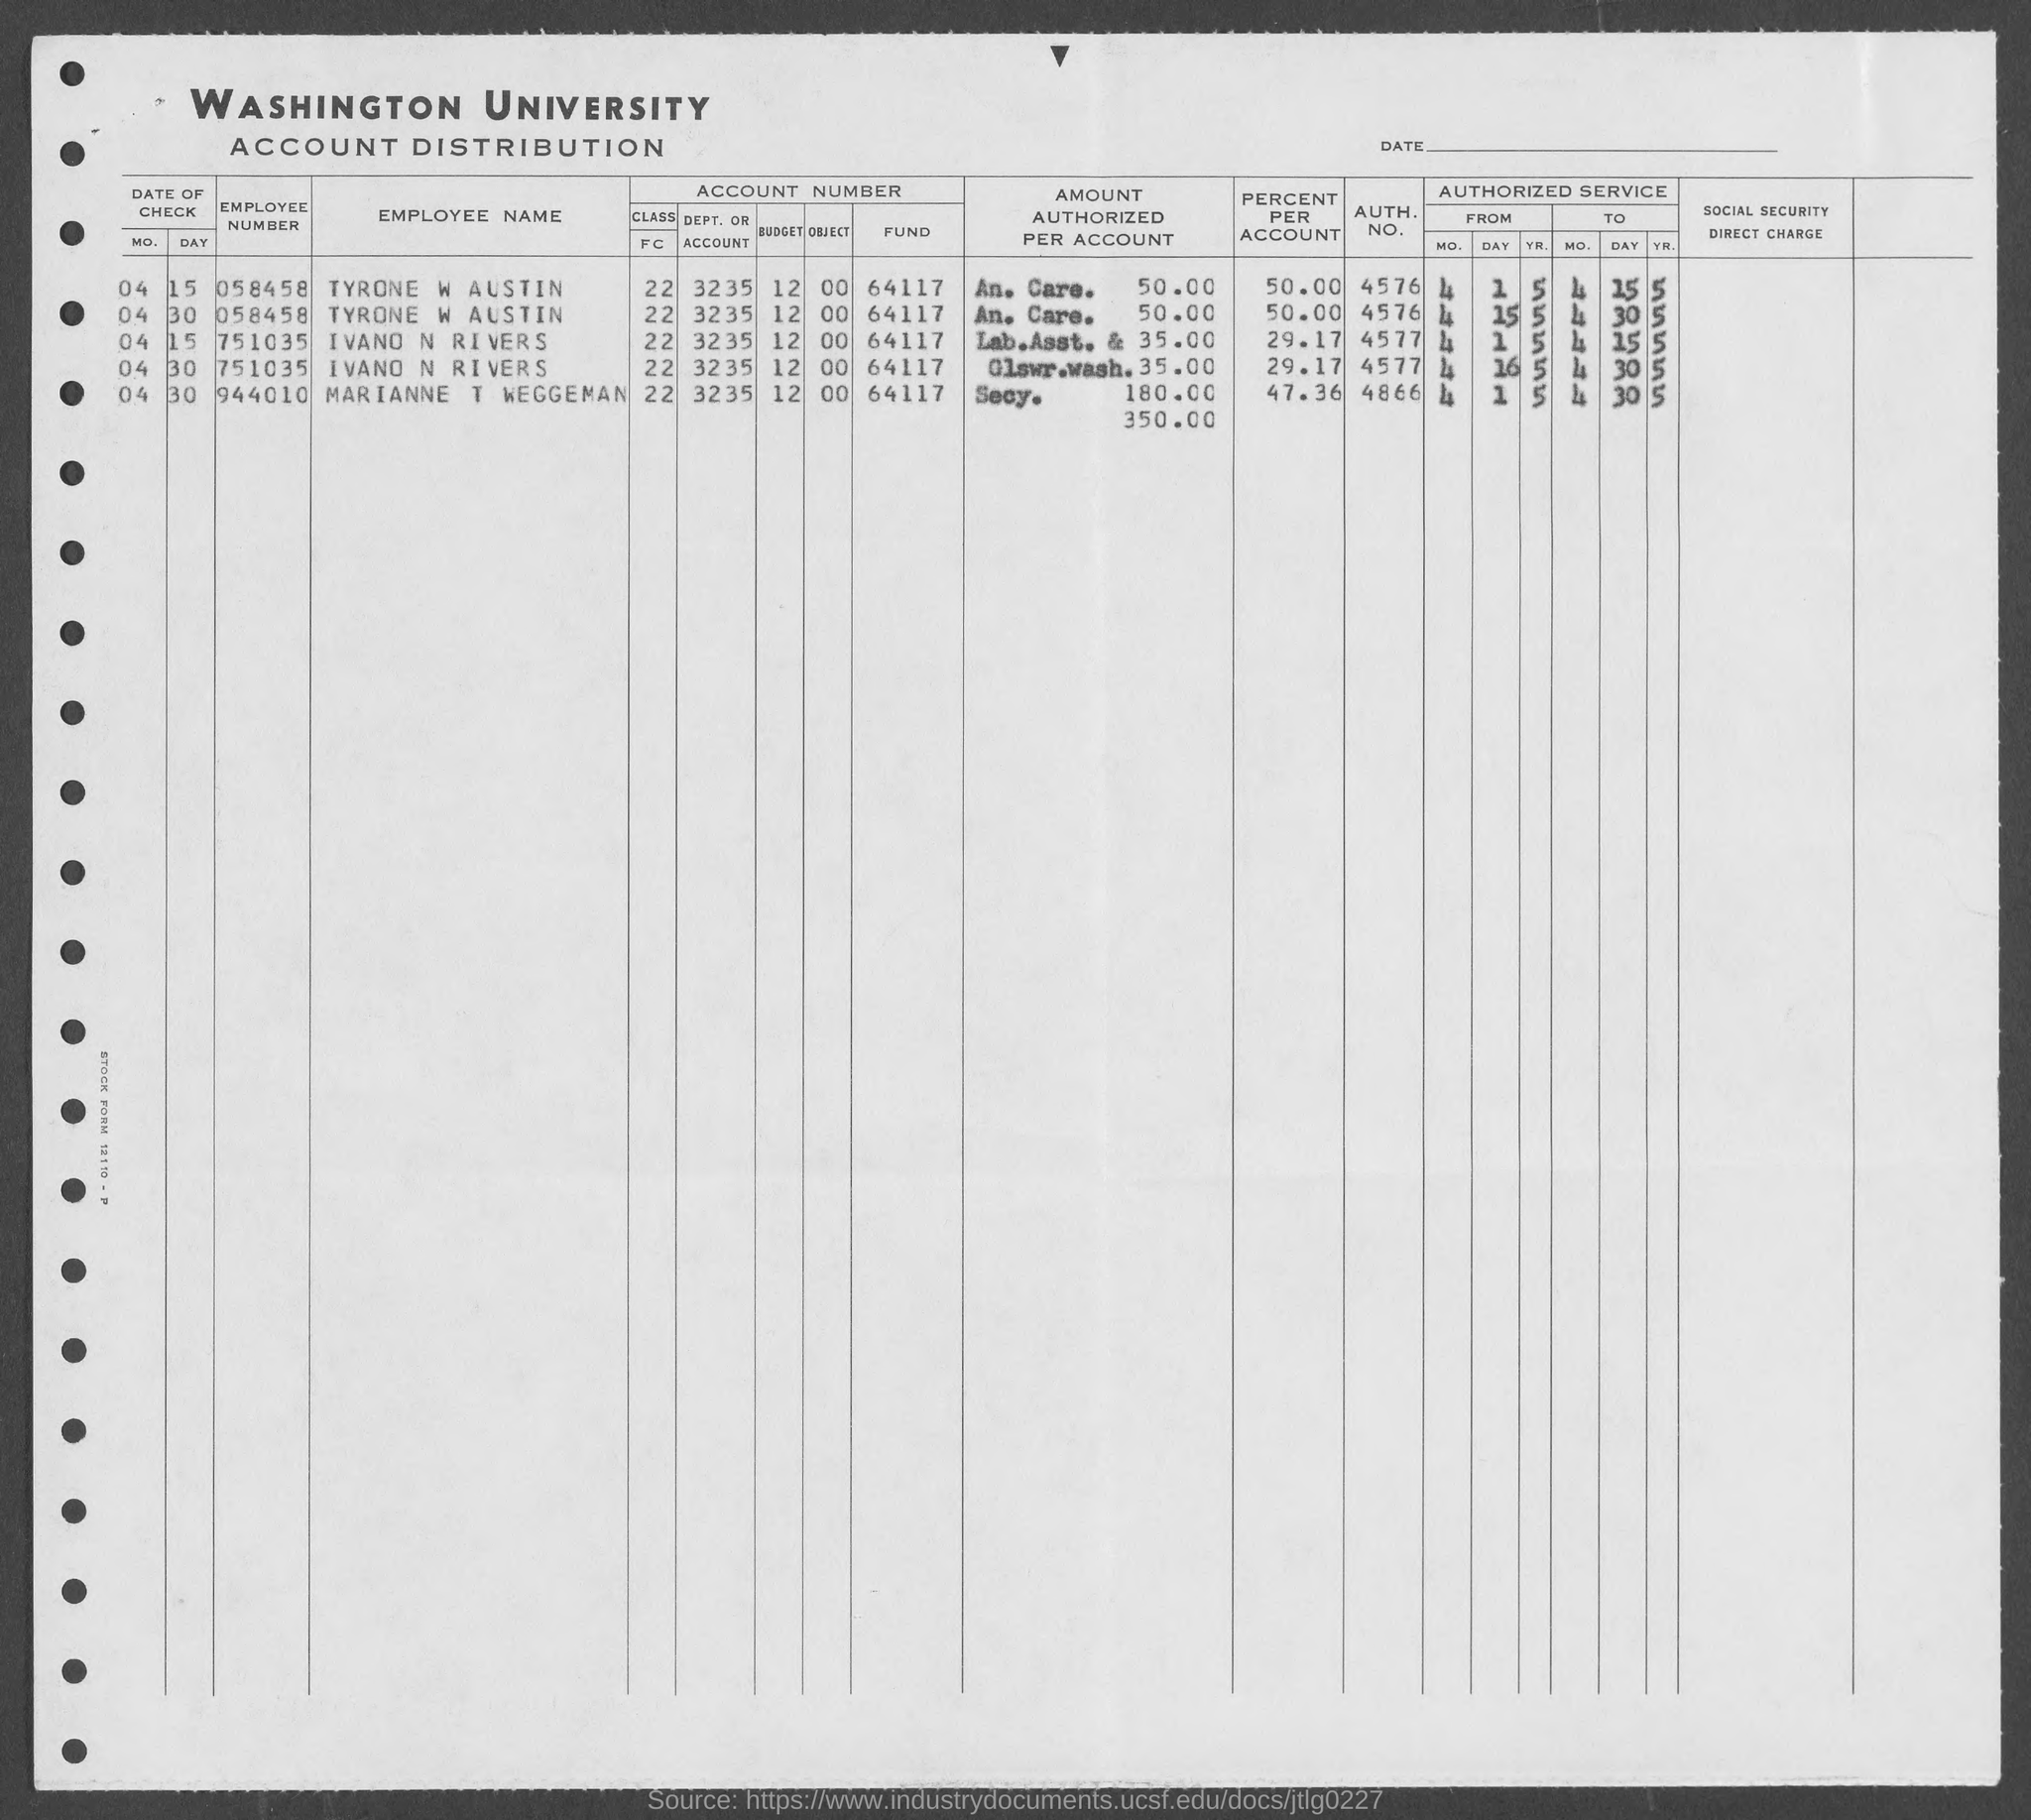What is the name of the university mentioned in the given form ?
Give a very brief answer. Washington university. What is the employee name given for the employee number 058458 as mentioned in the given form ?
Give a very brief answer. Tyrone w austin. What is the employee number given for marianne t waggeman  as mentioned in the given form ?
Your answer should be very brief. 944010. What is the employee number given for tyrone w austin as mentioned in the given form ?
Your response must be concise. 058458. 